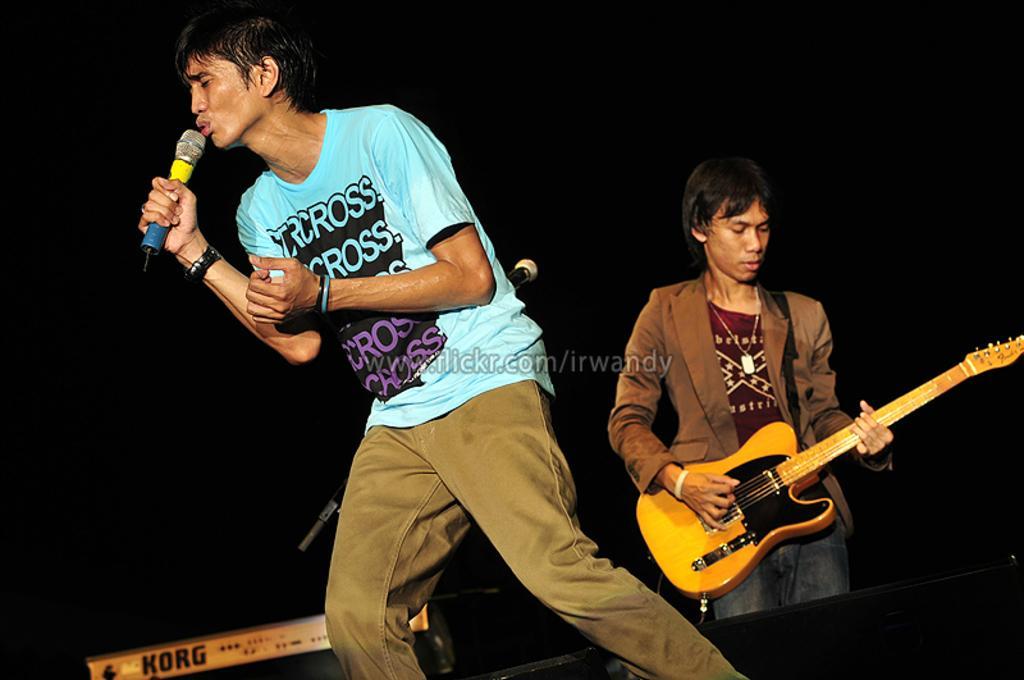In one or two sentences, can you explain what this image depicts? In this picture we can see two persons, a man singing with the help of microphone and another one is playing guitar, in the background we can see couple of musical instruments. 